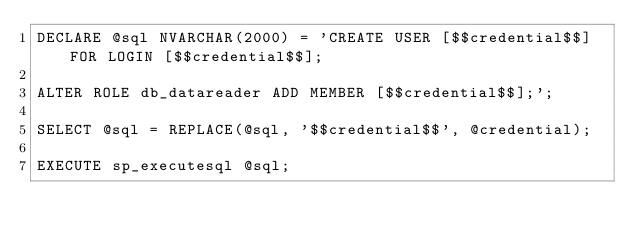<code> <loc_0><loc_0><loc_500><loc_500><_SQL_>DECLARE @sql NVARCHAR(2000) = 'CREATE USER [$$credential$$] FOR LOGIN [$$credential$$];

ALTER ROLE db_datareader ADD MEMBER [$$credential$$];';

SELECT @sql = REPLACE(@sql, '$$credential$$', @credential);

EXECUTE sp_executesql @sql;
</code> 